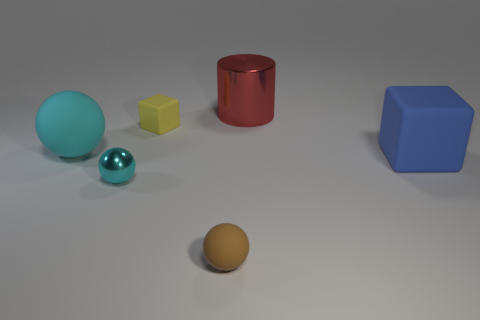Is the number of yellow matte things that are in front of the tiny brown matte sphere less than the number of small yellow things that are to the right of the small yellow matte thing? Upon careful inspection of the image, it appears that the number of yellow matte objects in front of the tiny brown matte sphere – which is one – is indeed less than the number of small yellow objects to the right of the small yellow matte object, since there are no small yellow items to its right. Therefore, the correct answer is yes, the quantity of yellow matte items in front of the brown sphere is less. 